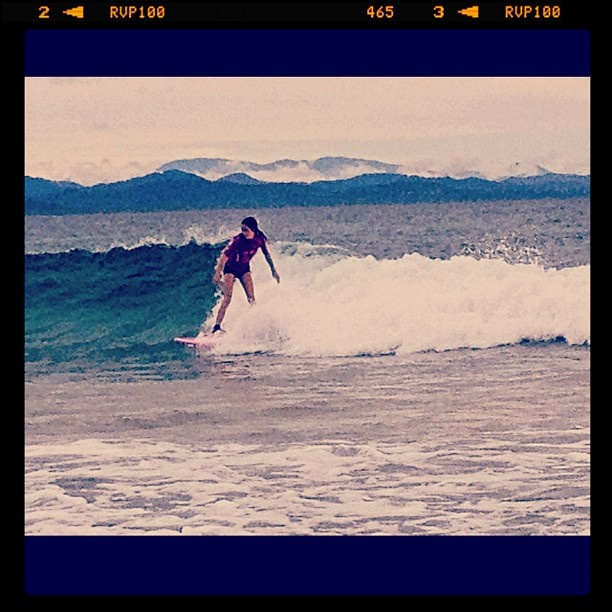Describe the objects in this image and their specific colors. I can see people in black, navy, brown, and purple tones and surfboard in black, lightpink, pink, darkgray, and gray tones in this image. 